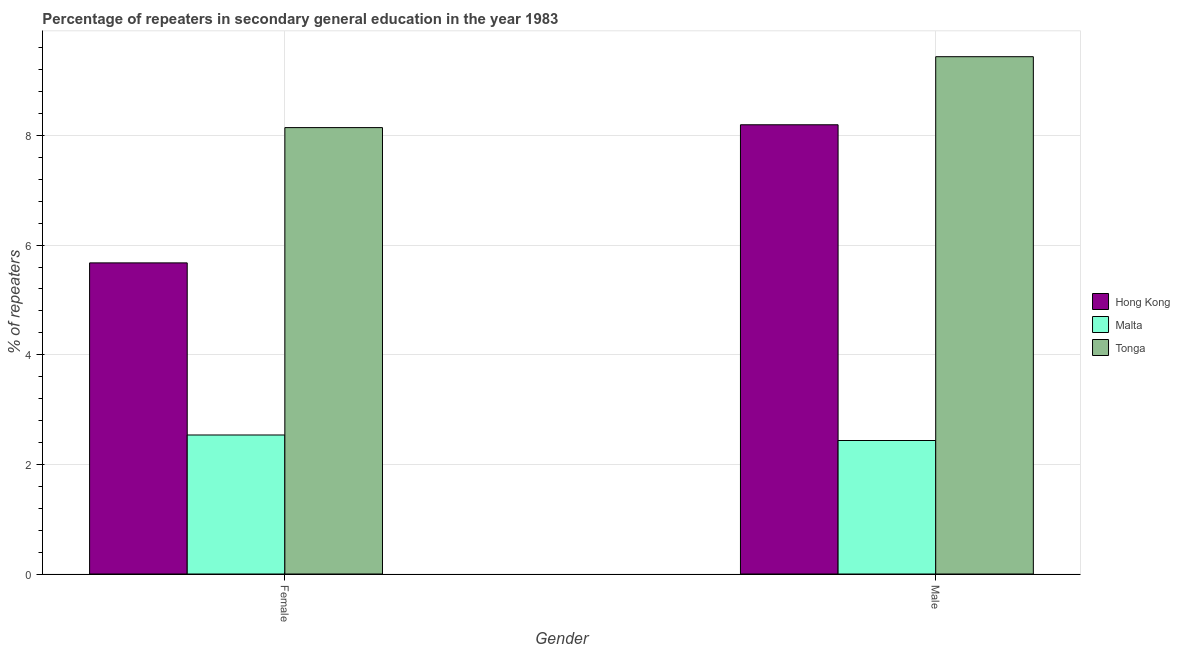How many different coloured bars are there?
Your answer should be very brief. 3. How many groups of bars are there?
Your answer should be very brief. 2. Are the number of bars per tick equal to the number of legend labels?
Provide a short and direct response. Yes. How many bars are there on the 2nd tick from the left?
Provide a succinct answer. 3. What is the percentage of female repeaters in Hong Kong?
Provide a succinct answer. 5.68. Across all countries, what is the maximum percentage of male repeaters?
Give a very brief answer. 9.44. Across all countries, what is the minimum percentage of male repeaters?
Your response must be concise. 2.44. In which country was the percentage of male repeaters maximum?
Keep it short and to the point. Tonga. In which country was the percentage of male repeaters minimum?
Offer a very short reply. Malta. What is the total percentage of female repeaters in the graph?
Your response must be concise. 16.36. What is the difference between the percentage of female repeaters in Hong Kong and that in Tonga?
Keep it short and to the point. -2.47. What is the difference between the percentage of female repeaters in Hong Kong and the percentage of male repeaters in Tonga?
Offer a terse response. -3.76. What is the average percentage of female repeaters per country?
Your answer should be very brief. 5.45. What is the difference between the percentage of female repeaters and percentage of male repeaters in Tonga?
Your answer should be very brief. -1.29. In how many countries, is the percentage of female repeaters greater than 6 %?
Give a very brief answer. 1. What is the ratio of the percentage of female repeaters in Malta to that in Hong Kong?
Your answer should be very brief. 0.45. In how many countries, is the percentage of male repeaters greater than the average percentage of male repeaters taken over all countries?
Your answer should be compact. 2. What does the 3rd bar from the left in Female represents?
Provide a succinct answer. Tonga. What does the 3rd bar from the right in Female represents?
Your answer should be very brief. Hong Kong. Where does the legend appear in the graph?
Provide a short and direct response. Center right. How many legend labels are there?
Your answer should be very brief. 3. How are the legend labels stacked?
Your response must be concise. Vertical. What is the title of the graph?
Your response must be concise. Percentage of repeaters in secondary general education in the year 1983. What is the label or title of the X-axis?
Keep it short and to the point. Gender. What is the label or title of the Y-axis?
Keep it short and to the point. % of repeaters. What is the % of repeaters of Hong Kong in Female?
Offer a terse response. 5.68. What is the % of repeaters of Malta in Female?
Provide a succinct answer. 2.54. What is the % of repeaters in Tonga in Female?
Ensure brevity in your answer.  8.14. What is the % of repeaters of Hong Kong in Male?
Your response must be concise. 8.2. What is the % of repeaters of Malta in Male?
Make the answer very short. 2.44. What is the % of repeaters in Tonga in Male?
Ensure brevity in your answer.  9.44. Across all Gender, what is the maximum % of repeaters in Hong Kong?
Keep it short and to the point. 8.2. Across all Gender, what is the maximum % of repeaters in Malta?
Your answer should be very brief. 2.54. Across all Gender, what is the maximum % of repeaters in Tonga?
Provide a succinct answer. 9.44. Across all Gender, what is the minimum % of repeaters of Hong Kong?
Your response must be concise. 5.68. Across all Gender, what is the minimum % of repeaters of Malta?
Give a very brief answer. 2.44. Across all Gender, what is the minimum % of repeaters of Tonga?
Offer a very short reply. 8.14. What is the total % of repeaters in Hong Kong in the graph?
Make the answer very short. 13.87. What is the total % of repeaters in Malta in the graph?
Make the answer very short. 4.97. What is the total % of repeaters in Tonga in the graph?
Your answer should be very brief. 17.58. What is the difference between the % of repeaters in Hong Kong in Female and that in Male?
Provide a short and direct response. -2.52. What is the difference between the % of repeaters of Malta in Female and that in Male?
Give a very brief answer. 0.1. What is the difference between the % of repeaters of Tonga in Female and that in Male?
Offer a very short reply. -1.29. What is the difference between the % of repeaters in Hong Kong in Female and the % of repeaters in Malta in Male?
Provide a succinct answer. 3.24. What is the difference between the % of repeaters in Hong Kong in Female and the % of repeaters in Tonga in Male?
Offer a very short reply. -3.76. What is the difference between the % of repeaters of Malta in Female and the % of repeaters of Tonga in Male?
Your response must be concise. -6.9. What is the average % of repeaters in Hong Kong per Gender?
Offer a terse response. 6.94. What is the average % of repeaters of Malta per Gender?
Provide a succinct answer. 2.49. What is the average % of repeaters in Tonga per Gender?
Make the answer very short. 8.79. What is the difference between the % of repeaters of Hong Kong and % of repeaters of Malta in Female?
Provide a short and direct response. 3.14. What is the difference between the % of repeaters in Hong Kong and % of repeaters in Tonga in Female?
Your response must be concise. -2.47. What is the difference between the % of repeaters in Malta and % of repeaters in Tonga in Female?
Give a very brief answer. -5.61. What is the difference between the % of repeaters of Hong Kong and % of repeaters of Malta in Male?
Give a very brief answer. 5.76. What is the difference between the % of repeaters in Hong Kong and % of repeaters in Tonga in Male?
Provide a short and direct response. -1.24. What is the difference between the % of repeaters of Malta and % of repeaters of Tonga in Male?
Your answer should be compact. -7. What is the ratio of the % of repeaters in Hong Kong in Female to that in Male?
Provide a short and direct response. 0.69. What is the ratio of the % of repeaters in Malta in Female to that in Male?
Ensure brevity in your answer.  1.04. What is the ratio of the % of repeaters of Tonga in Female to that in Male?
Provide a succinct answer. 0.86. What is the difference between the highest and the second highest % of repeaters of Hong Kong?
Offer a terse response. 2.52. What is the difference between the highest and the second highest % of repeaters in Malta?
Offer a terse response. 0.1. What is the difference between the highest and the second highest % of repeaters of Tonga?
Give a very brief answer. 1.29. What is the difference between the highest and the lowest % of repeaters in Hong Kong?
Offer a very short reply. 2.52. What is the difference between the highest and the lowest % of repeaters in Malta?
Make the answer very short. 0.1. What is the difference between the highest and the lowest % of repeaters in Tonga?
Provide a short and direct response. 1.29. 